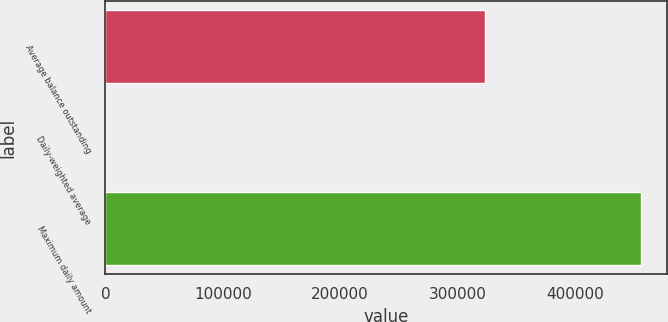Convert chart to OTSL. <chart><loc_0><loc_0><loc_500><loc_500><bar_chart><fcel>Average balance outstanding<fcel>Daily-weighted average<fcel>Maximum daily amount<nl><fcel>323429<fcel>1.3<fcel>455912<nl></chart> 